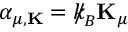<formula> <loc_0><loc_0><loc_500><loc_500>\alpha _ { \mu , { K } } = { \slash \, k } _ { \, { B } } { K } _ { \mu }</formula> 